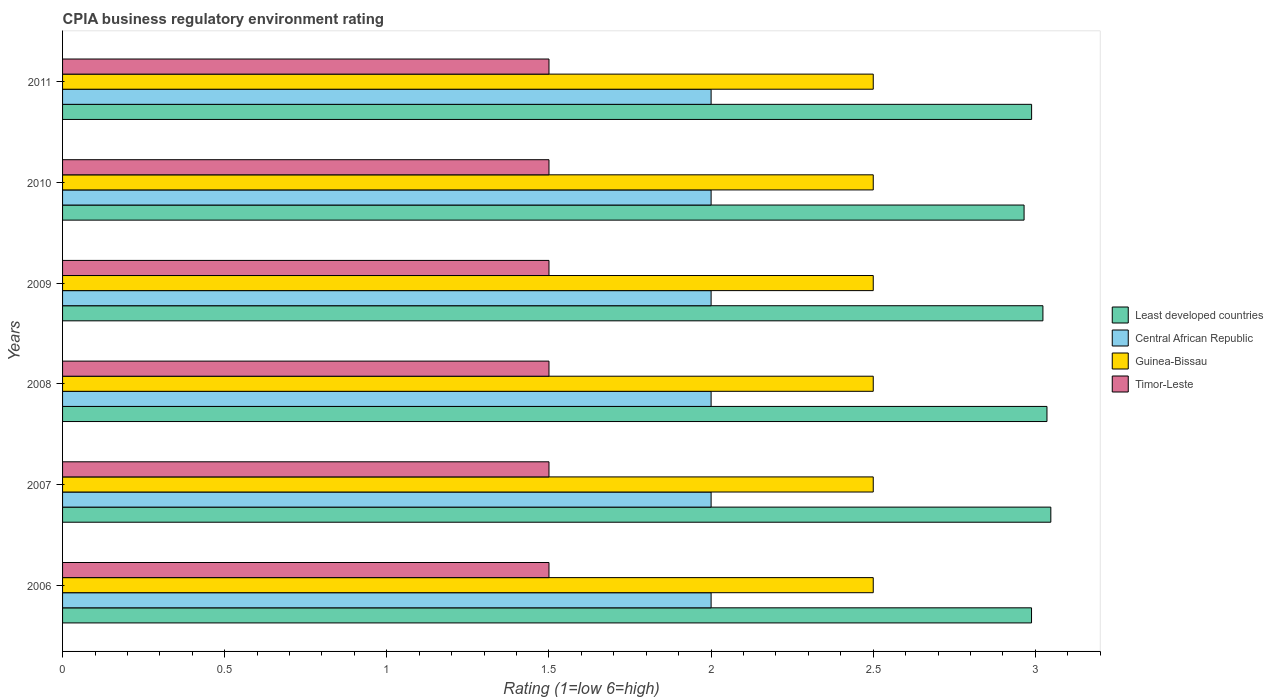How many different coloured bars are there?
Your answer should be very brief. 4. How many groups of bars are there?
Ensure brevity in your answer.  6. Are the number of bars per tick equal to the number of legend labels?
Provide a short and direct response. Yes. How many bars are there on the 4th tick from the top?
Your answer should be very brief. 4. What is the label of the 1st group of bars from the top?
Provide a short and direct response. 2011. In how many cases, is the number of bars for a given year not equal to the number of legend labels?
Ensure brevity in your answer.  0. What is the CPIA rating in Least developed countries in 2007?
Keep it short and to the point. 3.05. Across all years, what is the maximum CPIA rating in Timor-Leste?
Your response must be concise. 1.5. In which year was the CPIA rating in Timor-Leste maximum?
Offer a terse response. 2006. In which year was the CPIA rating in Timor-Leste minimum?
Your response must be concise. 2006. What is the total CPIA rating in Least developed countries in the graph?
Offer a terse response. 18.05. What is the difference between the CPIA rating in Central African Republic in 2007 and that in 2010?
Your response must be concise. 0. What is the difference between the CPIA rating in Least developed countries in 2006 and the CPIA rating in Central African Republic in 2008?
Offer a terse response. 0.99. In how many years, is the CPIA rating in Central African Republic greater than 2.2 ?
Give a very brief answer. 0. Is the difference between the CPIA rating in Timor-Leste in 2008 and 2010 greater than the difference between the CPIA rating in Central African Republic in 2008 and 2010?
Offer a very short reply. No. What is the difference between the highest and the second highest CPIA rating in Central African Republic?
Give a very brief answer. 0. What is the difference between the highest and the lowest CPIA rating in Timor-Leste?
Make the answer very short. 0. What does the 3rd bar from the top in 2006 represents?
Your answer should be very brief. Central African Republic. What does the 4th bar from the bottom in 2010 represents?
Your response must be concise. Timor-Leste. Are all the bars in the graph horizontal?
Keep it short and to the point. Yes. How many years are there in the graph?
Make the answer very short. 6. Are the values on the major ticks of X-axis written in scientific E-notation?
Give a very brief answer. No. Does the graph contain any zero values?
Give a very brief answer. No. Where does the legend appear in the graph?
Offer a very short reply. Center right. How many legend labels are there?
Provide a short and direct response. 4. How are the legend labels stacked?
Your response must be concise. Vertical. What is the title of the graph?
Your answer should be very brief. CPIA business regulatory environment rating. What is the label or title of the X-axis?
Provide a succinct answer. Rating (1=low 6=high). What is the Rating (1=low 6=high) of Least developed countries in 2006?
Give a very brief answer. 2.99. What is the Rating (1=low 6=high) of Central African Republic in 2006?
Offer a terse response. 2. What is the Rating (1=low 6=high) of Guinea-Bissau in 2006?
Your answer should be very brief. 2.5. What is the Rating (1=low 6=high) of Timor-Leste in 2006?
Make the answer very short. 1.5. What is the Rating (1=low 6=high) of Least developed countries in 2007?
Your response must be concise. 3.05. What is the Rating (1=low 6=high) of Guinea-Bissau in 2007?
Keep it short and to the point. 2.5. What is the Rating (1=low 6=high) in Least developed countries in 2008?
Ensure brevity in your answer.  3.04. What is the Rating (1=low 6=high) of Central African Republic in 2008?
Make the answer very short. 2. What is the Rating (1=low 6=high) in Guinea-Bissau in 2008?
Your answer should be very brief. 2.5. What is the Rating (1=low 6=high) in Timor-Leste in 2008?
Ensure brevity in your answer.  1.5. What is the Rating (1=low 6=high) of Least developed countries in 2009?
Provide a short and direct response. 3.02. What is the Rating (1=low 6=high) of Central African Republic in 2009?
Provide a short and direct response. 2. What is the Rating (1=low 6=high) in Guinea-Bissau in 2009?
Keep it short and to the point. 2.5. What is the Rating (1=low 6=high) of Timor-Leste in 2009?
Offer a very short reply. 1.5. What is the Rating (1=low 6=high) in Least developed countries in 2010?
Keep it short and to the point. 2.97. What is the Rating (1=low 6=high) of Guinea-Bissau in 2010?
Your response must be concise. 2.5. What is the Rating (1=low 6=high) of Timor-Leste in 2010?
Your response must be concise. 1.5. What is the Rating (1=low 6=high) in Least developed countries in 2011?
Offer a very short reply. 2.99. What is the Rating (1=low 6=high) in Guinea-Bissau in 2011?
Provide a short and direct response. 2.5. Across all years, what is the maximum Rating (1=low 6=high) in Least developed countries?
Your answer should be very brief. 3.05. Across all years, what is the maximum Rating (1=low 6=high) in Timor-Leste?
Offer a terse response. 1.5. Across all years, what is the minimum Rating (1=low 6=high) of Least developed countries?
Your answer should be very brief. 2.97. Across all years, what is the minimum Rating (1=low 6=high) of Central African Republic?
Offer a very short reply. 2. Across all years, what is the minimum Rating (1=low 6=high) of Timor-Leste?
Ensure brevity in your answer.  1.5. What is the total Rating (1=low 6=high) in Least developed countries in the graph?
Your answer should be compact. 18.05. What is the total Rating (1=low 6=high) of Central African Republic in the graph?
Make the answer very short. 12. What is the total Rating (1=low 6=high) of Timor-Leste in the graph?
Offer a very short reply. 9. What is the difference between the Rating (1=low 6=high) of Least developed countries in 2006 and that in 2007?
Provide a short and direct response. -0.06. What is the difference between the Rating (1=low 6=high) of Timor-Leste in 2006 and that in 2007?
Your answer should be very brief. 0. What is the difference between the Rating (1=low 6=high) of Least developed countries in 2006 and that in 2008?
Make the answer very short. -0.05. What is the difference between the Rating (1=low 6=high) of Timor-Leste in 2006 and that in 2008?
Provide a short and direct response. 0. What is the difference between the Rating (1=low 6=high) in Least developed countries in 2006 and that in 2009?
Your answer should be compact. -0.04. What is the difference between the Rating (1=low 6=high) in Least developed countries in 2006 and that in 2010?
Your response must be concise. 0.02. What is the difference between the Rating (1=low 6=high) of Central African Republic in 2006 and that in 2010?
Your response must be concise. 0. What is the difference between the Rating (1=low 6=high) in Guinea-Bissau in 2006 and that in 2010?
Your answer should be very brief. 0. What is the difference between the Rating (1=low 6=high) of Timor-Leste in 2006 and that in 2010?
Make the answer very short. 0. What is the difference between the Rating (1=low 6=high) in Least developed countries in 2006 and that in 2011?
Ensure brevity in your answer.  -0. What is the difference between the Rating (1=low 6=high) of Central African Republic in 2006 and that in 2011?
Give a very brief answer. 0. What is the difference between the Rating (1=low 6=high) in Guinea-Bissau in 2006 and that in 2011?
Your response must be concise. 0. What is the difference between the Rating (1=low 6=high) of Timor-Leste in 2006 and that in 2011?
Provide a short and direct response. 0. What is the difference between the Rating (1=low 6=high) of Least developed countries in 2007 and that in 2008?
Ensure brevity in your answer.  0.01. What is the difference between the Rating (1=low 6=high) in Central African Republic in 2007 and that in 2008?
Give a very brief answer. 0. What is the difference between the Rating (1=low 6=high) of Timor-Leste in 2007 and that in 2008?
Give a very brief answer. 0. What is the difference between the Rating (1=low 6=high) in Least developed countries in 2007 and that in 2009?
Provide a short and direct response. 0.02. What is the difference between the Rating (1=low 6=high) in Least developed countries in 2007 and that in 2010?
Ensure brevity in your answer.  0.08. What is the difference between the Rating (1=low 6=high) in Least developed countries in 2007 and that in 2011?
Provide a succinct answer. 0.06. What is the difference between the Rating (1=low 6=high) in Least developed countries in 2008 and that in 2009?
Offer a terse response. 0.01. What is the difference between the Rating (1=low 6=high) in Least developed countries in 2008 and that in 2010?
Give a very brief answer. 0.07. What is the difference between the Rating (1=low 6=high) in Guinea-Bissau in 2008 and that in 2010?
Provide a succinct answer. 0. What is the difference between the Rating (1=low 6=high) in Least developed countries in 2008 and that in 2011?
Provide a short and direct response. 0.05. What is the difference between the Rating (1=low 6=high) of Central African Republic in 2008 and that in 2011?
Your answer should be very brief. 0. What is the difference between the Rating (1=low 6=high) of Timor-Leste in 2008 and that in 2011?
Provide a short and direct response. 0. What is the difference between the Rating (1=low 6=high) in Least developed countries in 2009 and that in 2010?
Make the answer very short. 0.06. What is the difference between the Rating (1=low 6=high) of Central African Republic in 2009 and that in 2010?
Provide a succinct answer. 0. What is the difference between the Rating (1=low 6=high) in Least developed countries in 2009 and that in 2011?
Your response must be concise. 0.03. What is the difference between the Rating (1=low 6=high) in Central African Republic in 2009 and that in 2011?
Provide a succinct answer. 0. What is the difference between the Rating (1=low 6=high) of Least developed countries in 2010 and that in 2011?
Provide a succinct answer. -0.02. What is the difference between the Rating (1=low 6=high) of Central African Republic in 2010 and that in 2011?
Give a very brief answer. 0. What is the difference between the Rating (1=low 6=high) of Least developed countries in 2006 and the Rating (1=low 6=high) of Central African Republic in 2007?
Provide a short and direct response. 0.99. What is the difference between the Rating (1=low 6=high) in Least developed countries in 2006 and the Rating (1=low 6=high) in Guinea-Bissau in 2007?
Offer a terse response. 0.49. What is the difference between the Rating (1=low 6=high) in Least developed countries in 2006 and the Rating (1=low 6=high) in Timor-Leste in 2007?
Ensure brevity in your answer.  1.49. What is the difference between the Rating (1=low 6=high) in Central African Republic in 2006 and the Rating (1=low 6=high) in Guinea-Bissau in 2007?
Keep it short and to the point. -0.5. What is the difference between the Rating (1=low 6=high) in Guinea-Bissau in 2006 and the Rating (1=low 6=high) in Timor-Leste in 2007?
Offer a very short reply. 1. What is the difference between the Rating (1=low 6=high) in Least developed countries in 2006 and the Rating (1=low 6=high) in Central African Republic in 2008?
Provide a succinct answer. 0.99. What is the difference between the Rating (1=low 6=high) of Least developed countries in 2006 and the Rating (1=low 6=high) of Guinea-Bissau in 2008?
Your answer should be very brief. 0.49. What is the difference between the Rating (1=low 6=high) of Least developed countries in 2006 and the Rating (1=low 6=high) of Timor-Leste in 2008?
Offer a very short reply. 1.49. What is the difference between the Rating (1=low 6=high) in Central African Republic in 2006 and the Rating (1=low 6=high) in Guinea-Bissau in 2008?
Provide a short and direct response. -0.5. What is the difference between the Rating (1=low 6=high) in Guinea-Bissau in 2006 and the Rating (1=low 6=high) in Timor-Leste in 2008?
Your response must be concise. 1. What is the difference between the Rating (1=low 6=high) in Least developed countries in 2006 and the Rating (1=low 6=high) in Central African Republic in 2009?
Make the answer very short. 0.99. What is the difference between the Rating (1=low 6=high) in Least developed countries in 2006 and the Rating (1=low 6=high) in Guinea-Bissau in 2009?
Give a very brief answer. 0.49. What is the difference between the Rating (1=low 6=high) in Least developed countries in 2006 and the Rating (1=low 6=high) in Timor-Leste in 2009?
Make the answer very short. 1.49. What is the difference between the Rating (1=low 6=high) in Central African Republic in 2006 and the Rating (1=low 6=high) in Guinea-Bissau in 2009?
Keep it short and to the point. -0.5. What is the difference between the Rating (1=low 6=high) of Guinea-Bissau in 2006 and the Rating (1=low 6=high) of Timor-Leste in 2009?
Provide a succinct answer. 1. What is the difference between the Rating (1=low 6=high) of Least developed countries in 2006 and the Rating (1=low 6=high) of Central African Republic in 2010?
Provide a short and direct response. 0.99. What is the difference between the Rating (1=low 6=high) in Least developed countries in 2006 and the Rating (1=low 6=high) in Guinea-Bissau in 2010?
Give a very brief answer. 0.49. What is the difference between the Rating (1=low 6=high) of Least developed countries in 2006 and the Rating (1=low 6=high) of Timor-Leste in 2010?
Give a very brief answer. 1.49. What is the difference between the Rating (1=low 6=high) of Central African Republic in 2006 and the Rating (1=low 6=high) of Guinea-Bissau in 2010?
Ensure brevity in your answer.  -0.5. What is the difference between the Rating (1=low 6=high) in Central African Republic in 2006 and the Rating (1=low 6=high) in Timor-Leste in 2010?
Your answer should be very brief. 0.5. What is the difference between the Rating (1=low 6=high) in Least developed countries in 2006 and the Rating (1=low 6=high) in Central African Republic in 2011?
Provide a succinct answer. 0.99. What is the difference between the Rating (1=low 6=high) in Least developed countries in 2006 and the Rating (1=low 6=high) in Guinea-Bissau in 2011?
Ensure brevity in your answer.  0.49. What is the difference between the Rating (1=low 6=high) in Least developed countries in 2006 and the Rating (1=low 6=high) in Timor-Leste in 2011?
Ensure brevity in your answer.  1.49. What is the difference between the Rating (1=low 6=high) of Guinea-Bissau in 2006 and the Rating (1=low 6=high) of Timor-Leste in 2011?
Give a very brief answer. 1. What is the difference between the Rating (1=low 6=high) in Least developed countries in 2007 and the Rating (1=low 6=high) in Central African Republic in 2008?
Offer a terse response. 1.05. What is the difference between the Rating (1=low 6=high) of Least developed countries in 2007 and the Rating (1=low 6=high) of Guinea-Bissau in 2008?
Your answer should be very brief. 0.55. What is the difference between the Rating (1=low 6=high) of Least developed countries in 2007 and the Rating (1=low 6=high) of Timor-Leste in 2008?
Keep it short and to the point. 1.55. What is the difference between the Rating (1=low 6=high) in Central African Republic in 2007 and the Rating (1=low 6=high) in Guinea-Bissau in 2008?
Ensure brevity in your answer.  -0.5. What is the difference between the Rating (1=low 6=high) of Least developed countries in 2007 and the Rating (1=low 6=high) of Central African Republic in 2009?
Give a very brief answer. 1.05. What is the difference between the Rating (1=low 6=high) of Least developed countries in 2007 and the Rating (1=low 6=high) of Guinea-Bissau in 2009?
Ensure brevity in your answer.  0.55. What is the difference between the Rating (1=low 6=high) of Least developed countries in 2007 and the Rating (1=low 6=high) of Timor-Leste in 2009?
Provide a succinct answer. 1.55. What is the difference between the Rating (1=low 6=high) in Central African Republic in 2007 and the Rating (1=low 6=high) in Timor-Leste in 2009?
Ensure brevity in your answer.  0.5. What is the difference between the Rating (1=low 6=high) of Guinea-Bissau in 2007 and the Rating (1=low 6=high) of Timor-Leste in 2009?
Your response must be concise. 1. What is the difference between the Rating (1=low 6=high) of Least developed countries in 2007 and the Rating (1=low 6=high) of Central African Republic in 2010?
Your answer should be very brief. 1.05. What is the difference between the Rating (1=low 6=high) in Least developed countries in 2007 and the Rating (1=low 6=high) in Guinea-Bissau in 2010?
Offer a terse response. 0.55. What is the difference between the Rating (1=low 6=high) in Least developed countries in 2007 and the Rating (1=low 6=high) in Timor-Leste in 2010?
Your response must be concise. 1.55. What is the difference between the Rating (1=low 6=high) of Central African Republic in 2007 and the Rating (1=low 6=high) of Guinea-Bissau in 2010?
Keep it short and to the point. -0.5. What is the difference between the Rating (1=low 6=high) of Guinea-Bissau in 2007 and the Rating (1=low 6=high) of Timor-Leste in 2010?
Your response must be concise. 1. What is the difference between the Rating (1=low 6=high) of Least developed countries in 2007 and the Rating (1=low 6=high) of Central African Republic in 2011?
Offer a terse response. 1.05. What is the difference between the Rating (1=low 6=high) in Least developed countries in 2007 and the Rating (1=low 6=high) in Guinea-Bissau in 2011?
Your answer should be compact. 0.55. What is the difference between the Rating (1=low 6=high) in Least developed countries in 2007 and the Rating (1=low 6=high) in Timor-Leste in 2011?
Provide a succinct answer. 1.55. What is the difference between the Rating (1=low 6=high) of Central African Republic in 2007 and the Rating (1=low 6=high) of Guinea-Bissau in 2011?
Provide a short and direct response. -0.5. What is the difference between the Rating (1=low 6=high) of Central African Republic in 2007 and the Rating (1=low 6=high) of Timor-Leste in 2011?
Give a very brief answer. 0.5. What is the difference between the Rating (1=low 6=high) in Least developed countries in 2008 and the Rating (1=low 6=high) in Central African Republic in 2009?
Offer a terse response. 1.04. What is the difference between the Rating (1=low 6=high) in Least developed countries in 2008 and the Rating (1=low 6=high) in Guinea-Bissau in 2009?
Make the answer very short. 0.54. What is the difference between the Rating (1=low 6=high) of Least developed countries in 2008 and the Rating (1=low 6=high) of Timor-Leste in 2009?
Provide a short and direct response. 1.54. What is the difference between the Rating (1=low 6=high) of Central African Republic in 2008 and the Rating (1=low 6=high) of Guinea-Bissau in 2009?
Give a very brief answer. -0.5. What is the difference between the Rating (1=low 6=high) in Least developed countries in 2008 and the Rating (1=low 6=high) in Central African Republic in 2010?
Ensure brevity in your answer.  1.04. What is the difference between the Rating (1=low 6=high) of Least developed countries in 2008 and the Rating (1=low 6=high) of Guinea-Bissau in 2010?
Make the answer very short. 0.54. What is the difference between the Rating (1=low 6=high) of Least developed countries in 2008 and the Rating (1=low 6=high) of Timor-Leste in 2010?
Provide a succinct answer. 1.54. What is the difference between the Rating (1=low 6=high) of Central African Republic in 2008 and the Rating (1=low 6=high) of Guinea-Bissau in 2010?
Ensure brevity in your answer.  -0.5. What is the difference between the Rating (1=low 6=high) in Least developed countries in 2008 and the Rating (1=low 6=high) in Central African Republic in 2011?
Keep it short and to the point. 1.04. What is the difference between the Rating (1=low 6=high) of Least developed countries in 2008 and the Rating (1=low 6=high) of Guinea-Bissau in 2011?
Your answer should be compact. 0.54. What is the difference between the Rating (1=low 6=high) in Least developed countries in 2008 and the Rating (1=low 6=high) in Timor-Leste in 2011?
Make the answer very short. 1.54. What is the difference between the Rating (1=low 6=high) of Central African Republic in 2008 and the Rating (1=low 6=high) of Timor-Leste in 2011?
Offer a terse response. 0.5. What is the difference between the Rating (1=low 6=high) of Least developed countries in 2009 and the Rating (1=low 6=high) of Central African Republic in 2010?
Make the answer very short. 1.02. What is the difference between the Rating (1=low 6=high) in Least developed countries in 2009 and the Rating (1=low 6=high) in Guinea-Bissau in 2010?
Your response must be concise. 0.52. What is the difference between the Rating (1=low 6=high) of Least developed countries in 2009 and the Rating (1=low 6=high) of Timor-Leste in 2010?
Your answer should be compact. 1.52. What is the difference between the Rating (1=low 6=high) in Central African Republic in 2009 and the Rating (1=low 6=high) in Timor-Leste in 2010?
Your answer should be very brief. 0.5. What is the difference between the Rating (1=low 6=high) of Guinea-Bissau in 2009 and the Rating (1=low 6=high) of Timor-Leste in 2010?
Your answer should be very brief. 1. What is the difference between the Rating (1=low 6=high) in Least developed countries in 2009 and the Rating (1=low 6=high) in Central African Republic in 2011?
Keep it short and to the point. 1.02. What is the difference between the Rating (1=low 6=high) of Least developed countries in 2009 and the Rating (1=low 6=high) of Guinea-Bissau in 2011?
Ensure brevity in your answer.  0.52. What is the difference between the Rating (1=low 6=high) of Least developed countries in 2009 and the Rating (1=low 6=high) of Timor-Leste in 2011?
Give a very brief answer. 1.52. What is the difference between the Rating (1=low 6=high) of Central African Republic in 2009 and the Rating (1=low 6=high) of Guinea-Bissau in 2011?
Your response must be concise. -0.5. What is the difference between the Rating (1=low 6=high) in Central African Republic in 2009 and the Rating (1=low 6=high) in Timor-Leste in 2011?
Your answer should be very brief. 0.5. What is the difference between the Rating (1=low 6=high) of Least developed countries in 2010 and the Rating (1=low 6=high) of Central African Republic in 2011?
Keep it short and to the point. 0.97. What is the difference between the Rating (1=low 6=high) of Least developed countries in 2010 and the Rating (1=low 6=high) of Guinea-Bissau in 2011?
Your answer should be compact. 0.47. What is the difference between the Rating (1=low 6=high) of Least developed countries in 2010 and the Rating (1=low 6=high) of Timor-Leste in 2011?
Provide a succinct answer. 1.47. What is the difference between the Rating (1=low 6=high) in Central African Republic in 2010 and the Rating (1=low 6=high) in Guinea-Bissau in 2011?
Ensure brevity in your answer.  -0.5. What is the difference between the Rating (1=low 6=high) in Guinea-Bissau in 2010 and the Rating (1=low 6=high) in Timor-Leste in 2011?
Keep it short and to the point. 1. What is the average Rating (1=low 6=high) in Least developed countries per year?
Your response must be concise. 3.01. What is the average Rating (1=low 6=high) of Central African Republic per year?
Offer a very short reply. 2. What is the average Rating (1=low 6=high) of Guinea-Bissau per year?
Offer a very short reply. 2.5. What is the average Rating (1=low 6=high) of Timor-Leste per year?
Give a very brief answer. 1.5. In the year 2006, what is the difference between the Rating (1=low 6=high) of Least developed countries and Rating (1=low 6=high) of Guinea-Bissau?
Offer a very short reply. 0.49. In the year 2006, what is the difference between the Rating (1=low 6=high) of Least developed countries and Rating (1=low 6=high) of Timor-Leste?
Your answer should be very brief. 1.49. In the year 2006, what is the difference between the Rating (1=low 6=high) in Central African Republic and Rating (1=low 6=high) in Guinea-Bissau?
Offer a very short reply. -0.5. In the year 2006, what is the difference between the Rating (1=low 6=high) of Guinea-Bissau and Rating (1=low 6=high) of Timor-Leste?
Provide a short and direct response. 1. In the year 2007, what is the difference between the Rating (1=low 6=high) in Least developed countries and Rating (1=low 6=high) in Central African Republic?
Provide a short and direct response. 1.05. In the year 2007, what is the difference between the Rating (1=low 6=high) in Least developed countries and Rating (1=low 6=high) in Guinea-Bissau?
Offer a terse response. 0.55. In the year 2007, what is the difference between the Rating (1=low 6=high) of Least developed countries and Rating (1=low 6=high) of Timor-Leste?
Provide a succinct answer. 1.55. In the year 2007, what is the difference between the Rating (1=low 6=high) of Central African Republic and Rating (1=low 6=high) of Timor-Leste?
Offer a terse response. 0.5. In the year 2008, what is the difference between the Rating (1=low 6=high) of Least developed countries and Rating (1=low 6=high) of Central African Republic?
Provide a succinct answer. 1.04. In the year 2008, what is the difference between the Rating (1=low 6=high) in Least developed countries and Rating (1=low 6=high) in Guinea-Bissau?
Give a very brief answer. 0.54. In the year 2008, what is the difference between the Rating (1=low 6=high) in Least developed countries and Rating (1=low 6=high) in Timor-Leste?
Provide a short and direct response. 1.54. In the year 2009, what is the difference between the Rating (1=low 6=high) of Least developed countries and Rating (1=low 6=high) of Central African Republic?
Ensure brevity in your answer.  1.02. In the year 2009, what is the difference between the Rating (1=low 6=high) of Least developed countries and Rating (1=low 6=high) of Guinea-Bissau?
Make the answer very short. 0.52. In the year 2009, what is the difference between the Rating (1=low 6=high) in Least developed countries and Rating (1=low 6=high) in Timor-Leste?
Offer a very short reply. 1.52. In the year 2009, what is the difference between the Rating (1=low 6=high) of Central African Republic and Rating (1=low 6=high) of Guinea-Bissau?
Provide a succinct answer. -0.5. In the year 2009, what is the difference between the Rating (1=low 6=high) in Guinea-Bissau and Rating (1=low 6=high) in Timor-Leste?
Give a very brief answer. 1. In the year 2010, what is the difference between the Rating (1=low 6=high) in Least developed countries and Rating (1=low 6=high) in Central African Republic?
Your response must be concise. 0.97. In the year 2010, what is the difference between the Rating (1=low 6=high) of Least developed countries and Rating (1=low 6=high) of Guinea-Bissau?
Provide a short and direct response. 0.47. In the year 2010, what is the difference between the Rating (1=low 6=high) in Least developed countries and Rating (1=low 6=high) in Timor-Leste?
Your answer should be very brief. 1.47. In the year 2010, what is the difference between the Rating (1=low 6=high) of Guinea-Bissau and Rating (1=low 6=high) of Timor-Leste?
Your answer should be very brief. 1. In the year 2011, what is the difference between the Rating (1=low 6=high) of Least developed countries and Rating (1=low 6=high) of Central African Republic?
Provide a succinct answer. 0.99. In the year 2011, what is the difference between the Rating (1=low 6=high) in Least developed countries and Rating (1=low 6=high) in Guinea-Bissau?
Offer a very short reply. 0.49. In the year 2011, what is the difference between the Rating (1=low 6=high) in Least developed countries and Rating (1=low 6=high) in Timor-Leste?
Your response must be concise. 1.49. In the year 2011, what is the difference between the Rating (1=low 6=high) of Central African Republic and Rating (1=low 6=high) of Guinea-Bissau?
Offer a very short reply. -0.5. In the year 2011, what is the difference between the Rating (1=low 6=high) of Central African Republic and Rating (1=low 6=high) of Timor-Leste?
Keep it short and to the point. 0.5. What is the ratio of the Rating (1=low 6=high) of Least developed countries in 2006 to that in 2007?
Offer a terse response. 0.98. What is the ratio of the Rating (1=low 6=high) of Central African Republic in 2006 to that in 2007?
Keep it short and to the point. 1. What is the ratio of the Rating (1=low 6=high) of Timor-Leste in 2006 to that in 2007?
Provide a succinct answer. 1. What is the ratio of the Rating (1=low 6=high) of Least developed countries in 2006 to that in 2008?
Give a very brief answer. 0.98. What is the ratio of the Rating (1=low 6=high) in Timor-Leste in 2006 to that in 2008?
Offer a terse response. 1. What is the ratio of the Rating (1=low 6=high) in Least developed countries in 2006 to that in 2009?
Provide a short and direct response. 0.99. What is the ratio of the Rating (1=low 6=high) of Timor-Leste in 2006 to that in 2009?
Provide a short and direct response. 1. What is the ratio of the Rating (1=low 6=high) in Least developed countries in 2006 to that in 2010?
Ensure brevity in your answer.  1.01. What is the ratio of the Rating (1=low 6=high) in Guinea-Bissau in 2006 to that in 2010?
Give a very brief answer. 1. What is the ratio of the Rating (1=low 6=high) in Timor-Leste in 2006 to that in 2010?
Your answer should be very brief. 1. What is the ratio of the Rating (1=low 6=high) in Timor-Leste in 2006 to that in 2011?
Make the answer very short. 1. What is the ratio of the Rating (1=low 6=high) of Central African Republic in 2007 to that in 2008?
Your answer should be compact. 1. What is the ratio of the Rating (1=low 6=high) in Timor-Leste in 2007 to that in 2009?
Your response must be concise. 1. What is the ratio of the Rating (1=low 6=high) in Least developed countries in 2007 to that in 2010?
Keep it short and to the point. 1.03. What is the ratio of the Rating (1=low 6=high) in Least developed countries in 2007 to that in 2011?
Your answer should be compact. 1.02. What is the ratio of the Rating (1=low 6=high) in Timor-Leste in 2007 to that in 2011?
Make the answer very short. 1. What is the ratio of the Rating (1=low 6=high) in Central African Republic in 2008 to that in 2009?
Offer a terse response. 1. What is the ratio of the Rating (1=low 6=high) of Least developed countries in 2008 to that in 2010?
Your response must be concise. 1.02. What is the ratio of the Rating (1=low 6=high) in Central African Republic in 2008 to that in 2010?
Offer a terse response. 1. What is the ratio of the Rating (1=low 6=high) of Guinea-Bissau in 2008 to that in 2010?
Make the answer very short. 1. What is the ratio of the Rating (1=low 6=high) of Least developed countries in 2008 to that in 2011?
Make the answer very short. 1.02. What is the ratio of the Rating (1=low 6=high) of Central African Republic in 2008 to that in 2011?
Your answer should be very brief. 1. What is the ratio of the Rating (1=low 6=high) in Guinea-Bissau in 2008 to that in 2011?
Provide a short and direct response. 1. What is the ratio of the Rating (1=low 6=high) of Least developed countries in 2009 to that in 2010?
Make the answer very short. 1.02. What is the ratio of the Rating (1=low 6=high) in Central African Republic in 2009 to that in 2010?
Provide a succinct answer. 1. What is the ratio of the Rating (1=low 6=high) in Least developed countries in 2009 to that in 2011?
Give a very brief answer. 1.01. What is the ratio of the Rating (1=low 6=high) in Timor-Leste in 2009 to that in 2011?
Ensure brevity in your answer.  1. What is the ratio of the Rating (1=low 6=high) of Central African Republic in 2010 to that in 2011?
Your response must be concise. 1. What is the ratio of the Rating (1=low 6=high) of Guinea-Bissau in 2010 to that in 2011?
Provide a short and direct response. 1. What is the ratio of the Rating (1=low 6=high) in Timor-Leste in 2010 to that in 2011?
Your answer should be very brief. 1. What is the difference between the highest and the second highest Rating (1=low 6=high) in Least developed countries?
Make the answer very short. 0.01. What is the difference between the highest and the second highest Rating (1=low 6=high) of Central African Republic?
Your answer should be compact. 0. What is the difference between the highest and the second highest Rating (1=low 6=high) of Guinea-Bissau?
Ensure brevity in your answer.  0. What is the difference between the highest and the lowest Rating (1=low 6=high) of Least developed countries?
Your answer should be compact. 0.08. What is the difference between the highest and the lowest Rating (1=low 6=high) in Central African Republic?
Your response must be concise. 0. What is the difference between the highest and the lowest Rating (1=low 6=high) in Guinea-Bissau?
Offer a terse response. 0. 